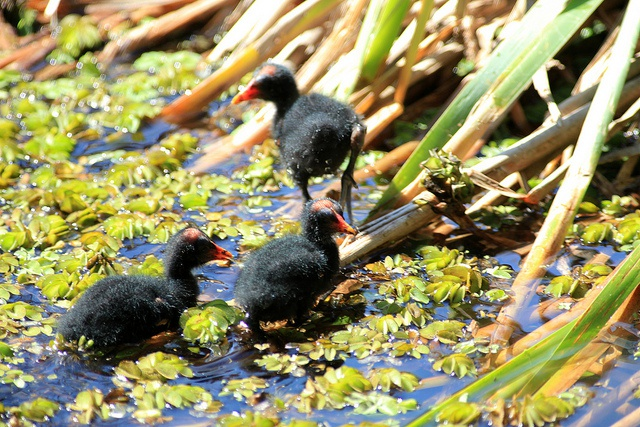Describe the objects in this image and their specific colors. I can see bird in olive, black, gray, purple, and darkgray tones, bird in olive, black, gray, and darkgray tones, and bird in olive, black, gray, and darkgray tones in this image. 